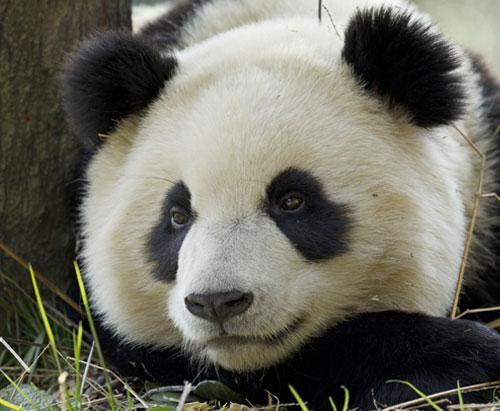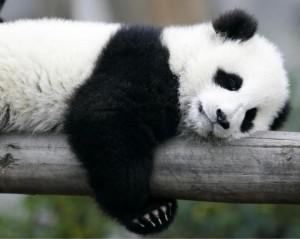The first image is the image on the left, the second image is the image on the right. Given the left and right images, does the statement "In one image there is a panda bear sleeping on a log." hold true? Answer yes or no. Yes. 